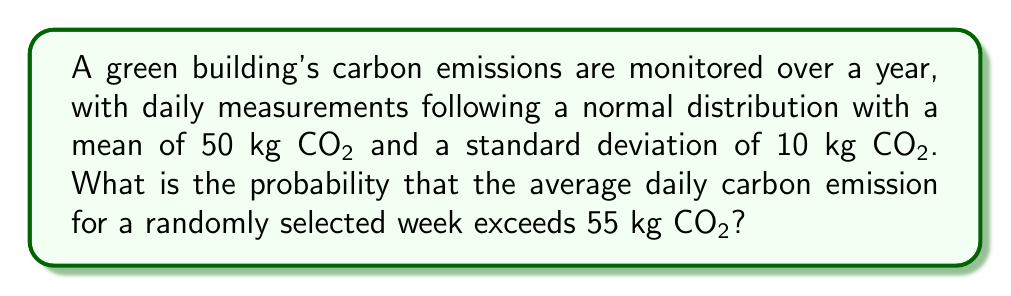Can you answer this question? Let's approach this step-by-step:

1) First, we need to understand what we're calculating. We're looking for the probability that the mean of 7 daily measurements (one week) exceeds 55 kg CO₂.

2) We know that the daily measurements follow a normal distribution with:
   $\mu = 50$ kg CO₂ (mean)
   $\sigma = 10$ kg CO₂ (standard deviation)

3) The Central Limit Theorem tells us that the distribution of sample means will also be normal, with:
   $\mu_{\bar{x}} = \mu = 50$ kg CO₂
   $\sigma_{\bar{x}} = \frac{\sigma}{\sqrt{n}} = \frac{10}{\sqrt{7}} \approx 3.78$ kg CO₂

4) We want to find $P(\bar{X} > 55)$, where $\bar{X}$ is the mean of 7 days.

5) To use the standard normal distribution, we need to standardize our value:
   $$z = \frac{55 - \mu_{\bar{x}}}{\sigma_{\bar{x}}} = \frac{55 - 50}{3.78} \approx 1.32$$

6) Now we need to find $P(Z > 1.32)$ where $Z$ is a standard normal variable.

7) Using a standard normal table or calculator, we find:
   $P(Z > 1.32) = 1 - P(Z < 1.32) \approx 1 - 0.9066 \approx 0.0934$

8) Therefore, the probability that the average daily carbon emission for a randomly selected week exceeds 55 kg CO₂ is approximately 0.0934 or 9.34%.
Answer: 0.0934 or 9.34% 